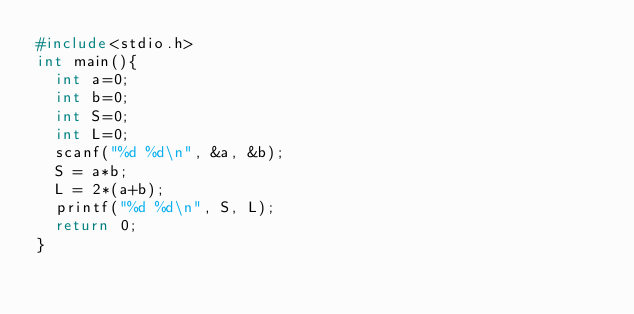Convert code to text. <code><loc_0><loc_0><loc_500><loc_500><_C_>#include<stdio.h>
int main(){
	int a=0;
	int b=0;
	int S=0;
	int L=0;
	scanf("%d %d\n", &a, &b);
	S = a*b;
	L = 2*(a+b);
	printf("%d %d\n", S, L);
	return 0;
}
</code> 